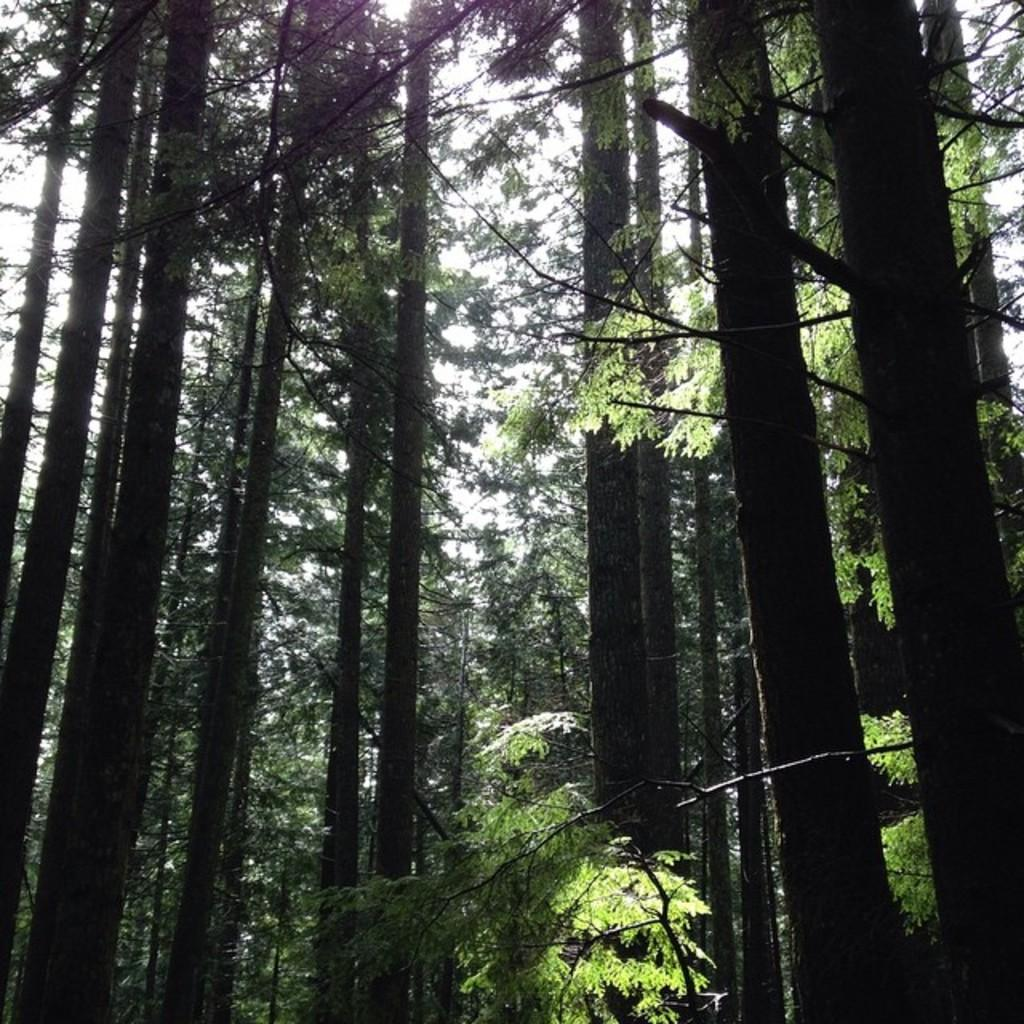What type of vegetation can be seen in the image? There are trees in the image. What is the weather like in the image? The sky is sunny in the image, suggesting a clear and bright day. Is there any quicksand visible in the image? No, there is no quicksand present in the image. What time of day is depicted in the image? The provided facts do not mention the time of day, but the sunny sky suggests it is during the day. 